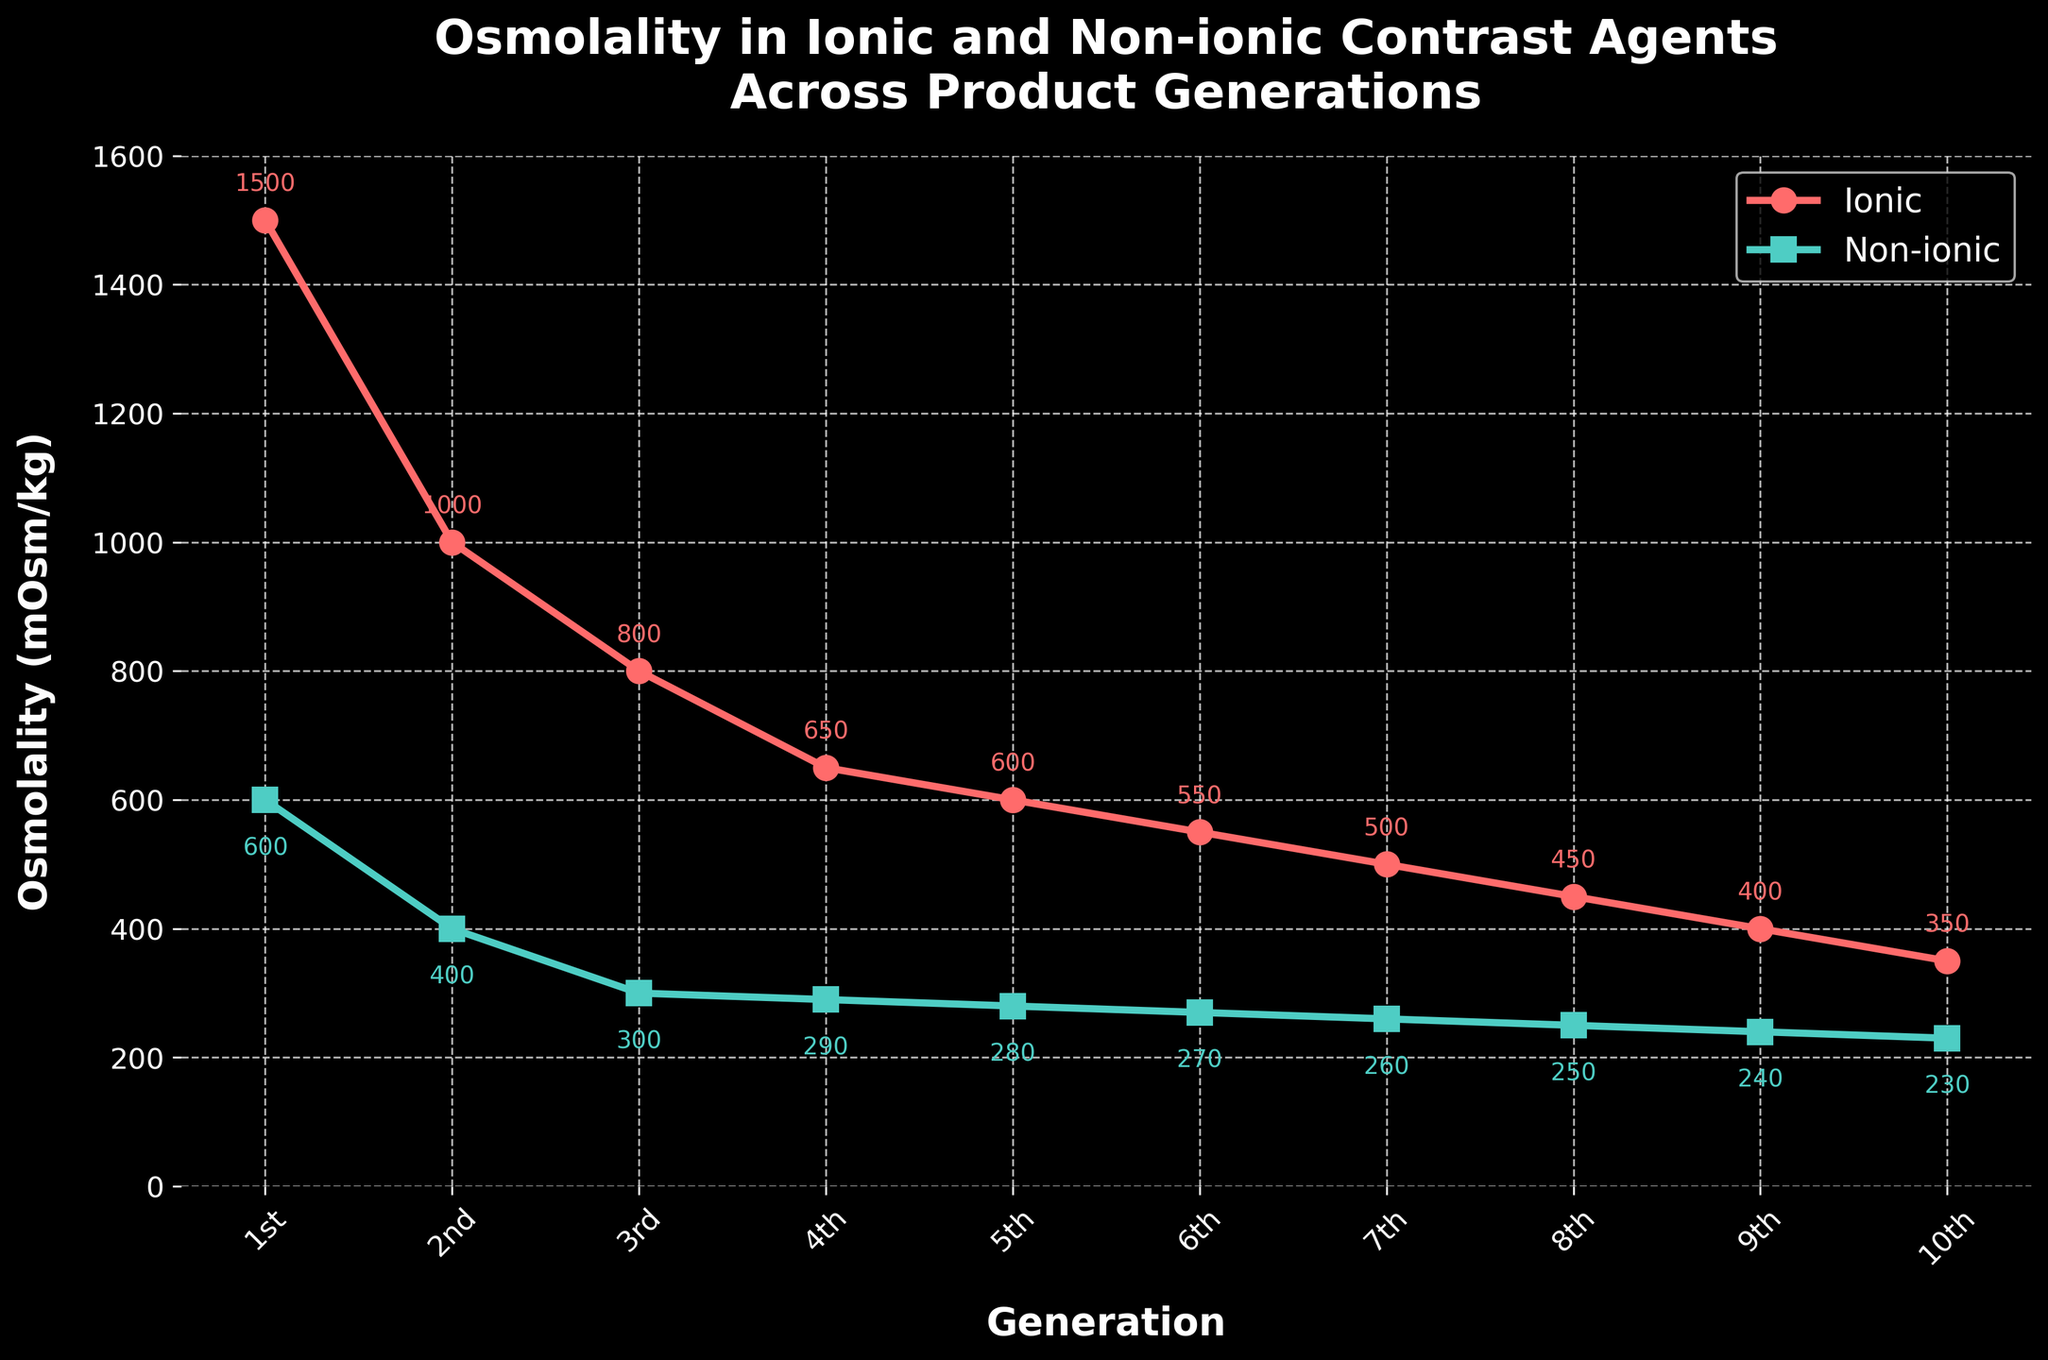Which contrast agent has the highest osmolality in the 1st generation? The highest osmolality value is visible at the first generation point on the chart. The ionic contrast agent has an osmolality of 1500 mOsm/kg in the 1st generation, which is higher than 600 mOsm/kg for the non-ionic contrast agent.
Answer: Ionic How does the osmolality of ionic agents change from the 1st generation to the 10th generation? To determine the change, subtract the osmolality of the ionic agent in the 10th generation (350 mOsm/kg) from the osmolality in the 1st generation (1500 mOsm/kg). The change is 1500 - 350 = 1150 mOsm/kg.
Answer: Decreases by 1150 mOsm/kg In which generation is the osmolality of non-ionic contrast agents lower than 300 mOsm/kg? By visually inspecting the chart, we see that the non-ionic contrast agents have osmolality values lower than 300 mOsm/kg starting from the 4th generation onwards.
Answer: 4th generation onwards What is the difference in osmolality between ionic and non-ionic contrast agents in the 6th generation? The difference is found by subtracting the osmolality of the non-ionic agent (270 mOsm/kg) from the ionic agent (550 mOsm/kg) in the 6th generation. This results in 550 - 270 = 280 mOsm/kg.
Answer: 280 mOsm/kg Which generation shows the smallest gap in osmolality between ionic and non-ionic contrast agents? Visually comparing the gaps in osmolality across generations, the smallest gap occurs in the 10th generation, where the values are 350 mOsm/kg and 230 mOsm/kg respectively. The gap is 120 mOsm/kg.
Answer: 10th generation What trends can be observed in the osmolality of the ionic and non-ionic agents over generations? The osmolality of both ionic and non-ionic contrast agents declines as the generations progress. The rate of decline is steeper for ionic agents compared to non-ionic agents, leading to a reduced difference between the two over time.
Answer: Declining trend, steep decline in ionic What are the osmolality values of both ionic and non-ionic contrast agents in the 3rd generation? Look at the generation labeled '3rd' on the x-axis. The values displayed are 800 mOsm/kg for ionic agents and 300 mOsm/kg for non-ionic agents.
Answer: 800 mOsm/kg (ionic), 300 mOsm/kg (non-ionic) By how much does the osmolality of non-ionic contrast agents change from the 4th to the 8th generation? The change in osmolality is found by subtracting the value in the 8th generation (250 mOsm/kg) from the value in the 4th generation (290 mOsm/kg). The difference is 290 - 250 = 40 mOsm/kg.
Answer: Decreases by 40 mOsm/kg 